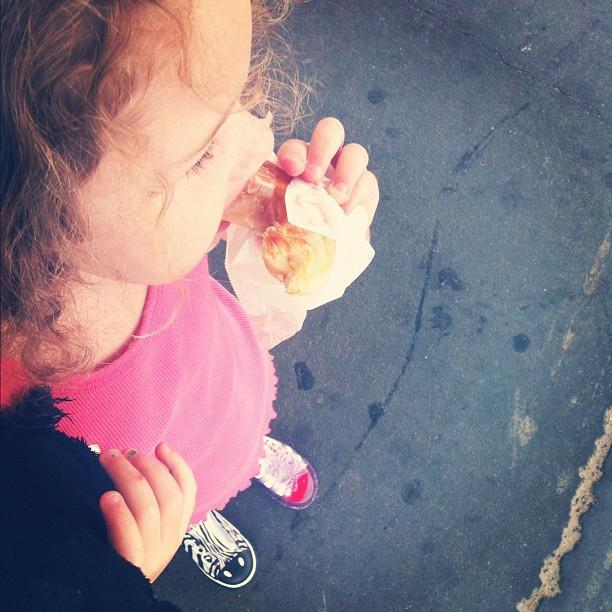What color is one of the girl's shoes?

Choices:
A) orange
B) black
C) green
D) blue black 